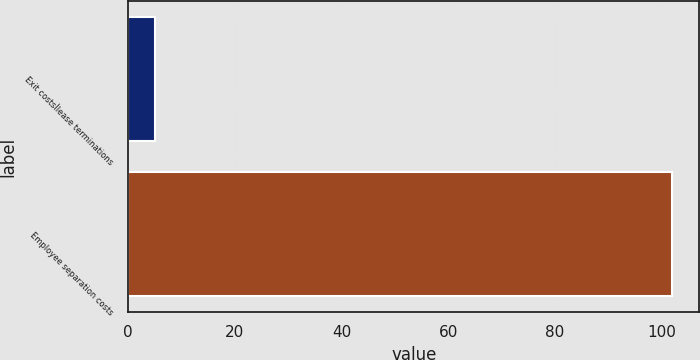<chart> <loc_0><loc_0><loc_500><loc_500><bar_chart><fcel>Exit costsÌlease terminations<fcel>Employee separation costs<nl><fcel>5<fcel>102<nl></chart> 